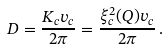Convert formula to latex. <formula><loc_0><loc_0><loc_500><loc_500>D = \frac { K _ { c } v _ { c } } { 2 \pi } = \frac { \xi _ { c } ^ { 2 } ( Q ) v _ { c } } { 2 \pi } \, .</formula> 